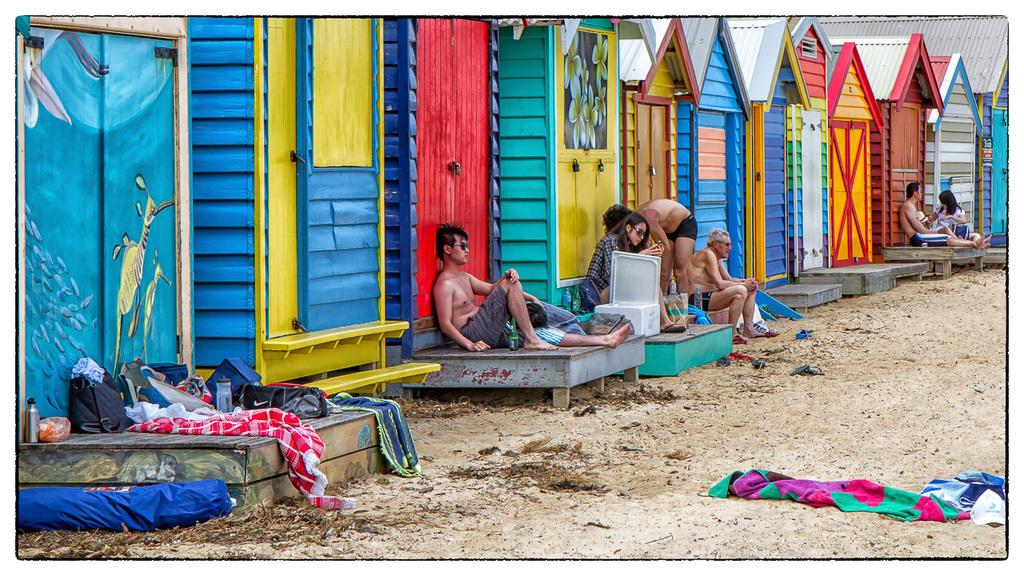How many people are in the image? There are people in the image, but the exact number is not specified. What are some of the people doing in the image? Some people are sitting, and one person is bending. What type of structures can be seen in the image? There are houses in the image. What is present on the ground in the image? Clothes and other objects are visible on the ground. What note is the person playing on the guitar in the image? There is no guitar or note mentioned in the image; it only states that one person is bending. How much shade is provided by the trees in the image? There is no mention of trees or shade in the image. 